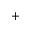<formula> <loc_0><loc_0><loc_500><loc_500>+</formula> 